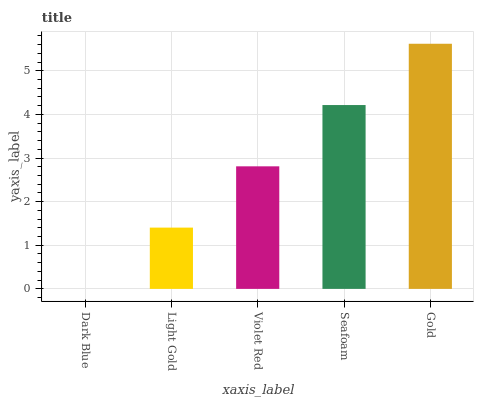Is Dark Blue the minimum?
Answer yes or no. Yes. Is Gold the maximum?
Answer yes or no. Yes. Is Light Gold the minimum?
Answer yes or no. No. Is Light Gold the maximum?
Answer yes or no. No. Is Light Gold greater than Dark Blue?
Answer yes or no. Yes. Is Dark Blue less than Light Gold?
Answer yes or no. Yes. Is Dark Blue greater than Light Gold?
Answer yes or no. No. Is Light Gold less than Dark Blue?
Answer yes or no. No. Is Violet Red the high median?
Answer yes or no. Yes. Is Violet Red the low median?
Answer yes or no. Yes. Is Light Gold the high median?
Answer yes or no. No. Is Gold the low median?
Answer yes or no. No. 